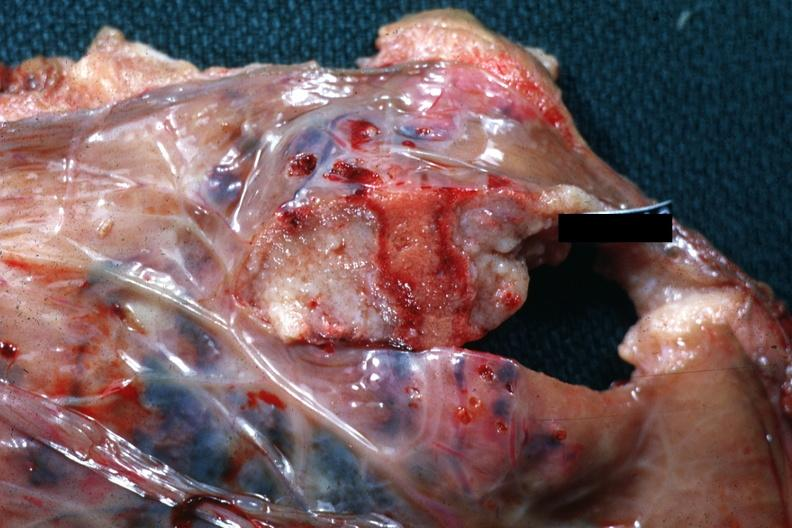what is present?
Answer the question using a single word or phrase. Female reproductive 